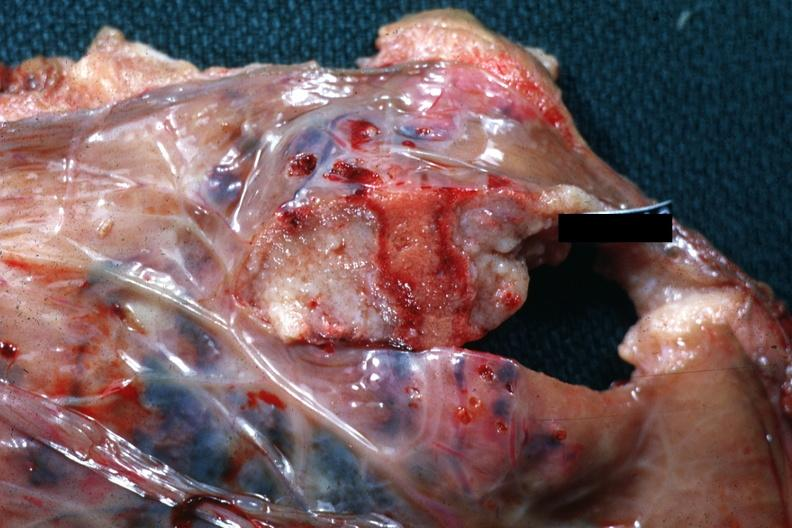what is present?
Answer the question using a single word or phrase. Female reproductive 